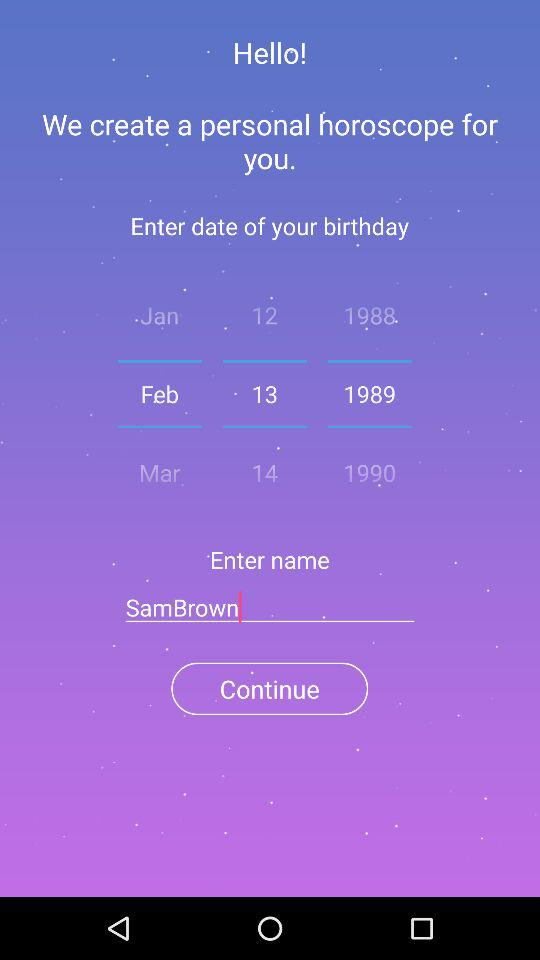How many options are there for the month of birth?
Answer the question using a single word or phrase. 3 